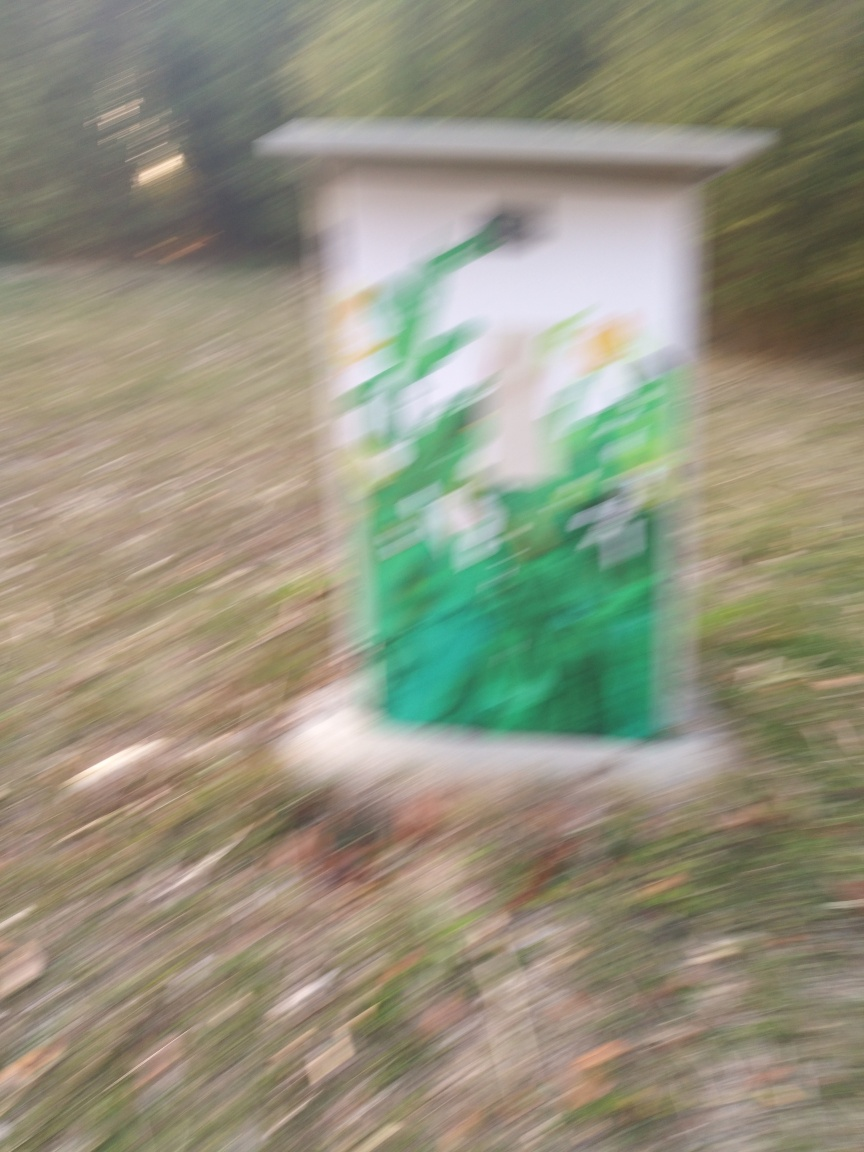What is the overall clarity of this image?
A. moderate
B. excellent
C. high
D. low The overall clarity of this image is low, as it is quite blurred and details are not easily discernible. This suggests that the picture may have been taken while the camera was moving or with an unfocused lens, resulting in a lack of sharpness and definition in the image. 